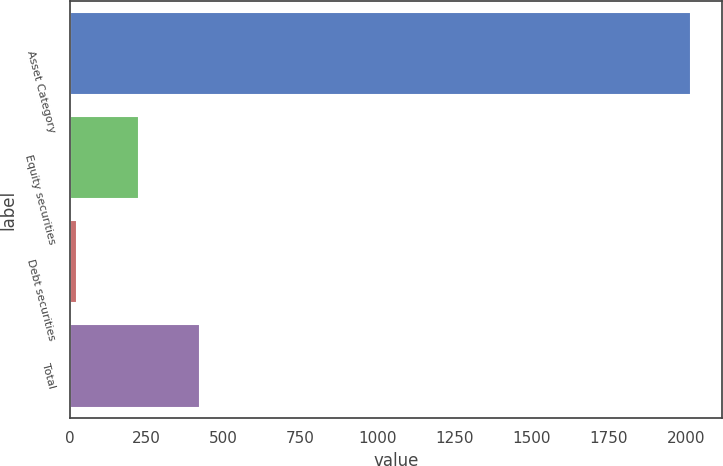Convert chart. <chart><loc_0><loc_0><loc_500><loc_500><bar_chart><fcel>Asset Category<fcel>Equity securities<fcel>Debt securities<fcel>Total<nl><fcel>2017<fcel>224.39<fcel>25.21<fcel>423.57<nl></chart> 